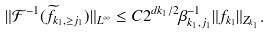Convert formula to latex. <formula><loc_0><loc_0><loc_500><loc_500>\| \mathcal { F } ^ { - 1 } ( \widetilde { f } _ { k _ { 1 } , \geq j _ { 1 } } ) \| _ { L ^ { \infty } } \leq C 2 ^ { d k _ { 1 } / 2 } \beta _ { k _ { 1 } , j _ { 1 } } ^ { - 1 } \| f _ { k _ { 1 } } \| _ { Z _ { k _ { 1 } } } .</formula> 